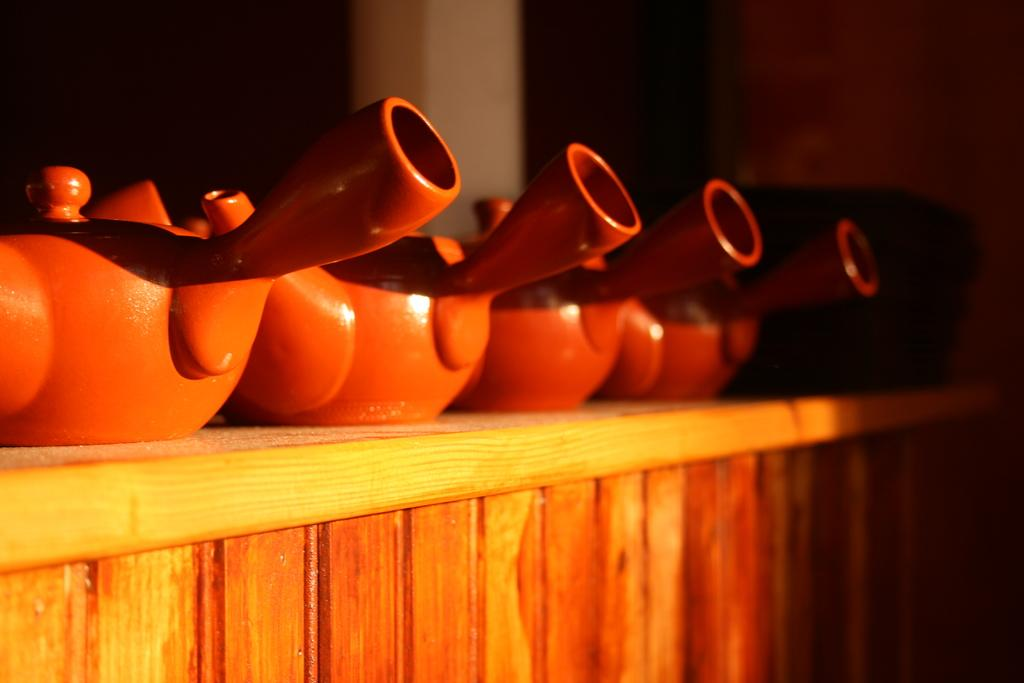Where was the image taken? The image was taken indoors. What can be seen in the background of the image? There is a wall in the background of the image. What type of furniture is at the bottom of the image? There is a wooden table at the bottom of the image. What items are on the wooden table? There are kettles and a basket on the wooden table. How many crows are sitting on the kettles in the image? There are no crows present in the image; it features kettles and a basket on a wooden table. 